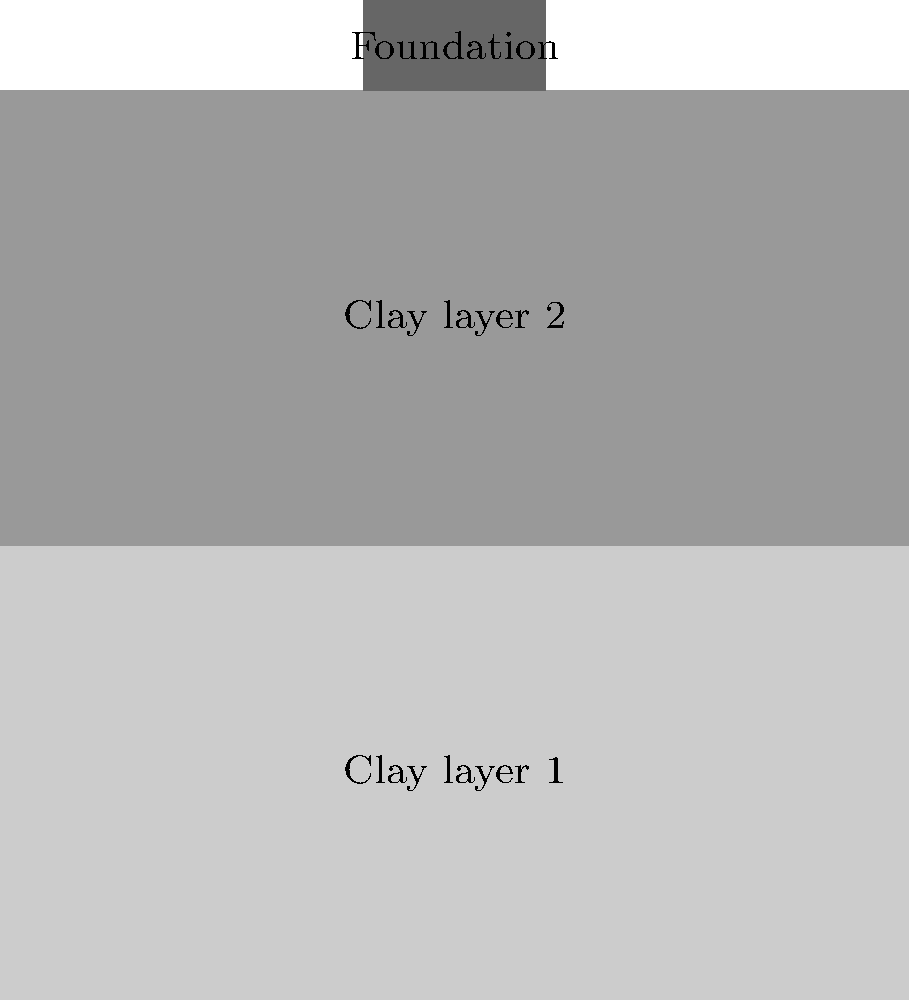As a civil engineer working on a project in Brunei, you need to calculate the total settlement of a shallow foundation on a two-layer cohesive soil. The foundation is 2 m wide and applies a pressure of 200 kPa. The soil profile consists of two clay layers, each 5 m thick. The first layer has an initial void ratio (e₁) of 0.9 and a compression index (C_c) of 0.3, while the second layer has an initial void ratio (e₂) of 0.7 and a compression index (C_c) of 0.2. The effective overburden pressure at the middle of the first layer is 25 kPa, and at the middle of the second layer is 75 kPa. Calculate the total settlement of the foundation. To calculate the total settlement, we'll use the consolidation settlement equation for each layer and sum the results. The equation for consolidation settlement is:

$$ S = H \cdot \frac{C_c}{1 + e_0} \cdot \log_{10}\left(\frac{\sigma'_0 + \Delta\sigma}{\sigma'_0}\right) $$

Where:
- $S$ is the settlement
- $H$ is the layer thickness
- $C_c$ is the compression index
- $e_0$ is the initial void ratio
- $\sigma'_0$ is the initial effective stress
- $\Delta\sigma$ is the change in stress

Step 1: Calculate $\Delta\sigma$ at the middle of each layer
For a 2:1 stress distribution:
$\Delta\sigma_1 = 200 \cdot \frac{2 \cdot 2}{2 \cdot 2 + 2.5} = 123.1$ kPa
$\Delta\sigma_2 = 200 \cdot \frac{2 \cdot 2}{2 \cdot 2 + 7.5} = 64.5$ kPa

Step 2: Calculate settlement for Layer 1
$$ S_1 = 5 \cdot \frac{0.3}{1 + 0.9} \cdot \log_{10}\left(\frac{25 + 123.1}{25}\right) = 0.237 \text{ m} $$

Step 3: Calculate settlement for Layer 2
$$ S_2 = 5 \cdot \frac{0.2}{1 + 0.7} \cdot \log_{10}\left(\frac{75 + 64.5}{75}\right) = 0.058 \text{ m} $$

Step 4: Calculate total settlement
$S_{total} = S_1 + S_2 = 0.237 + 0.058 = 0.295 \text{ m}$
Answer: 0.295 m 